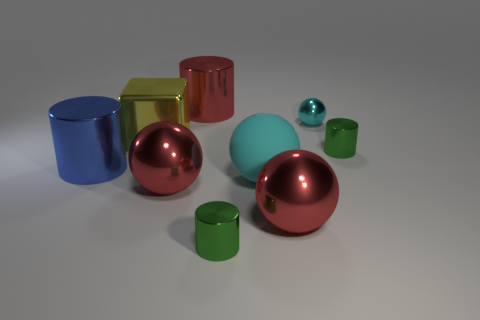Is the matte thing the same color as the tiny sphere?
Your response must be concise. Yes. How big is the blue shiny thing?
Ensure brevity in your answer.  Large. There is a red ball that is on the left side of the green metallic thing that is in front of the large matte ball that is to the right of the large yellow cube; how big is it?
Offer a very short reply. Large. What is the size of the other ball that is the same color as the tiny ball?
Keep it short and to the point. Large. There is a cylinder that is to the left of the cyan metallic object and behind the large blue thing; what size is it?
Provide a short and direct response. Large. What material is the cyan sphere that is behind the large cylinder in front of the cyan shiny object that is on the right side of the large blue object made of?
Make the answer very short. Metal. There is a sphere that is the same color as the big rubber thing; what is its material?
Your answer should be very brief. Metal. There is a large metallic object to the right of the big red metallic cylinder; does it have the same color as the large shiny cylinder behind the blue shiny thing?
Your answer should be compact. Yes. What shape is the big yellow shiny thing that is in front of the cylinder behind the tiny cyan sphere that is on the right side of the big blue metal cylinder?
Offer a terse response. Cube. There is a thing that is to the right of the matte ball and behind the big yellow block; what shape is it?
Make the answer very short. Sphere. 